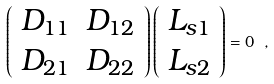<formula> <loc_0><loc_0><loc_500><loc_500>\left ( \begin{array} { c c } D _ { 1 1 } & D _ { 1 2 } \\ D _ { 2 1 } & D _ { 2 2 } \end{array} \right ) \left ( \begin{array} { c } L _ { s 1 } \\ L _ { s 2 } \end{array} \right ) = 0 \ ,</formula> 